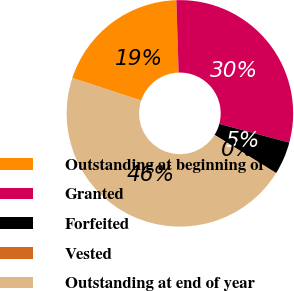Convert chart. <chart><loc_0><loc_0><loc_500><loc_500><pie_chart><fcel>Outstanding at beginning of<fcel>Granted<fcel>Forfeited<fcel>Vested<fcel>Outstanding at end of year<nl><fcel>19.46%<fcel>29.65%<fcel>4.67%<fcel>0.07%<fcel>46.15%<nl></chart> 